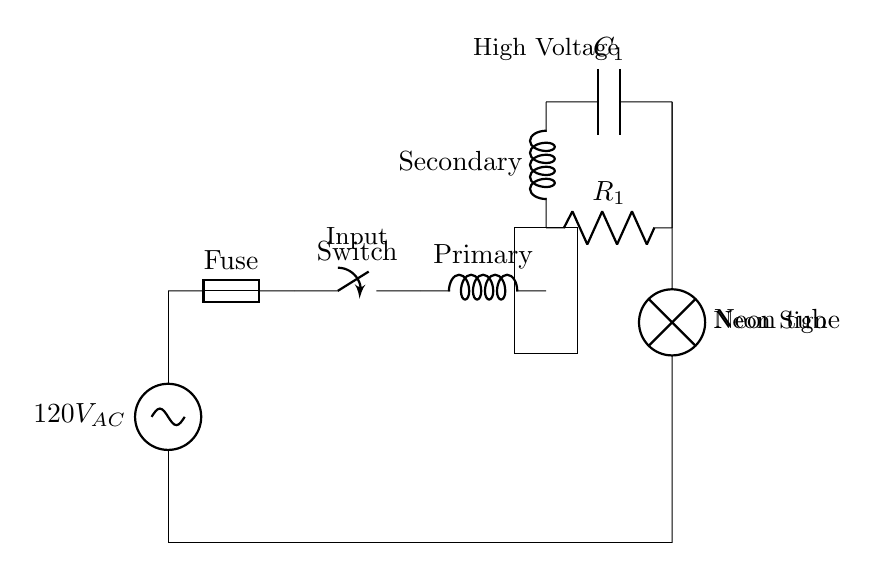What is the input voltage of the circuit? The input voltage is indicated at the AC source label in the circuit diagram. It states "120V AC", which signifies the alternating current input.
Answer: 120V AC What component is used to limit current in the circuit? The circuit contains a ballast resistor labeled R1. This component serves to limit the current flowing through the neon tube, ensuring safe operation.
Answer: R1 What is the role of the transformer in this circuit? The transformer has primary and secondary windings and is responsible for stepping up the voltage from the input AC voltage to a much higher voltage required for the neon tube operation.
Answer: Step-up What types of components are connected in series in this circuit? To identify the components connected in series, we can trace the path from the AC source through the fuse, the switch, the primary winding, the secondary winding, and the high voltage capacitor before reaching the neon tube. All these elements share the same current path sequentially.
Answer: Fuse, Switch, Primary, Secondary, C1, Neon Tube How does the high voltage capacitor contribute to the neon sign operation? The high voltage capacitor C1 stores charge and releases it, creating the high voltage needed to ionize the gas within the neon tube. Ionization allows the neon to glow, which is the primary function of the neon sign.
Answer: Stores charge What happens if the fuse blows in this circuit? If the fuse blows, it creates an open circuit, breaking the flow of current through the entire circuit. This would cause the neon sign to turn off and prevent any high voltage from reaching the neon tube, safeguarding it from damage.
Answer: Circuit stops 